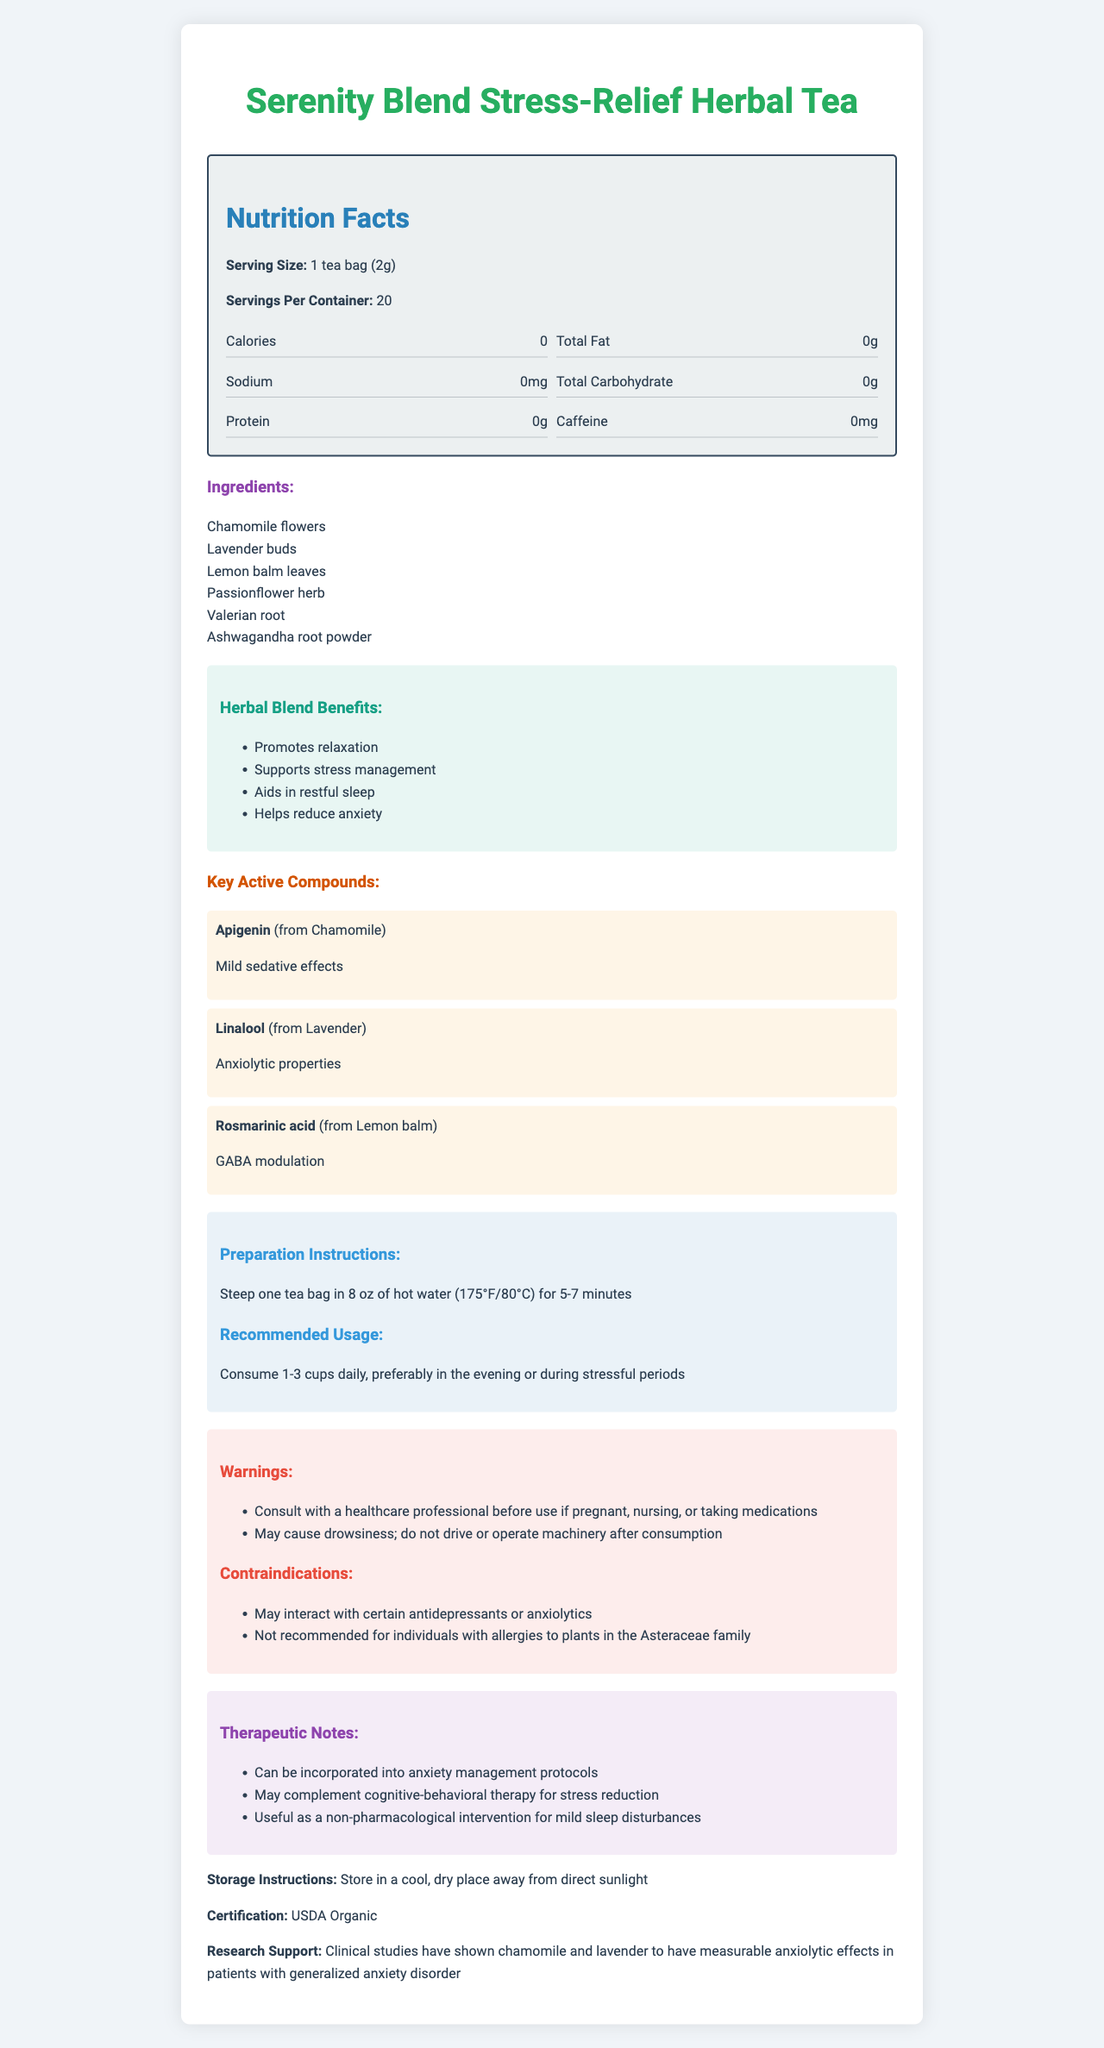what is the serving size for the Serenity Blend Stress-Relief Herbal Tea? According to the document, the serving size is detailed as 1 tea bag weighing 2 grams.
Answer: 1 tea bag (2g) how many servings are there per container? The document specifies that there are 20 servings per container.
Answer: 20 name three ingredients found in the herbal tea blend. The document lists six ingredients, including Chamomile flowers, Lavender buds, and Lemon balm leaves.
Answer: Chamomile flowers, Lavender buds, Lemon balm leaves list two benefits of the herbal blend. The benefits section of the document lists multiple benefits, including promoting relaxation and supporting stress management.
Answer: Promotes relaxation, Supports stress management what is the caffeine content of the tea? The document states that the caffeine content of the tea is 0mg.
Answer: 0mg which compound in the tea is known for its anxiolytic properties? A. Apigenin B. Linalool C. Rosmarinic acid The key active compounds section explains that Linalool, sourced from Lavender, has anxiolytic properties.
Answer: B. Linalool what is the certification of the Serenity Blend Stress-Relief Herbal Tea? A. USDA Organic B. Non-GMO Project Verified C. Fair Trade Certified The document mentions that the tea is certified USDA Organic.
Answer: A. USDA Organic is it recommended to operate machinery after consuming the tea? One of the warnings states that the tea may cause drowsiness and advises not to drive or operate machinery after consumption.
Answer: No summarize the main idea of the document. The document provides detailed information on the Serenity Blend Stress-Relief Herbal Tea, including its benefits, ingredients, active compounds, nutritional facts, preparation instructions, recommended usage, storage instructions, certification, warnings, and therapeutic applications.
Answer: The Serenity Blend Stress-Relief Herbal Tea is a USDA Organic herbal tea blend designed to promote relaxation, aid in stress management, and support restful sleep. It is caffeine-free and contains ingredients like Chamomile, Lavender, and Lemon balm, with key compounds like Apigenin and Linalool known for their calming effects. The document provides information on serving size, preparation instructions, benefits, warnings, and therapeutic notes. what is the recommended daily intake of the tea? The document recommends consuming 1-3 cups daily, preferably in the evening or during stressful periods.
Answer: 1-3 cups daily does the document provide information about interactions with medications? The warnings section advises consulting with a healthcare professional before use if pregnant, nursing, or taking medications.
Answer: Yes can this tea be used as a complementary treatment for cognitive-behavioral therapy? The therapeutic notes state that the tea may complement cognitive-behavioral therapy for stress reduction.
Answer: Yes what clinical evidence supports the anxiolytic effects of the tea? The research support section mentions clinical studies showing chamomile and lavender's efficacy in reducing anxiety in patients with generalized anxiety disorder.
Answer: Clinical studies have shown chamomile and lavender to have measurable anxiolytic effects in patients with generalized anxiety disorder can you confirm the manufacturing process of the tea? The document does not provide any information regarding the manufacturing process of the tea.
Answer: Cannot be determined 